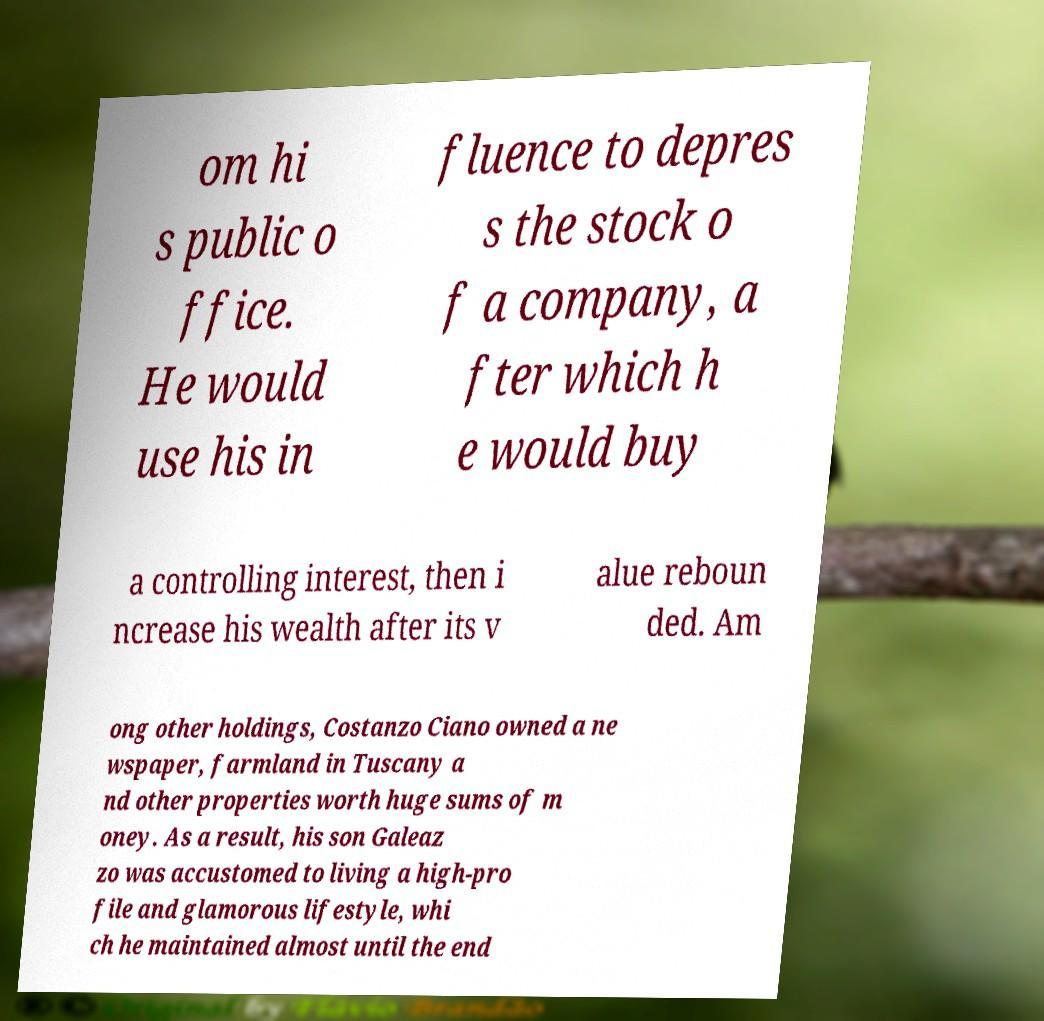I need the written content from this picture converted into text. Can you do that? om hi s public o ffice. He would use his in fluence to depres s the stock o f a company, a fter which h e would buy a controlling interest, then i ncrease his wealth after its v alue reboun ded. Am ong other holdings, Costanzo Ciano owned a ne wspaper, farmland in Tuscany a nd other properties worth huge sums of m oney. As a result, his son Galeaz zo was accustomed to living a high-pro file and glamorous lifestyle, whi ch he maintained almost until the end 